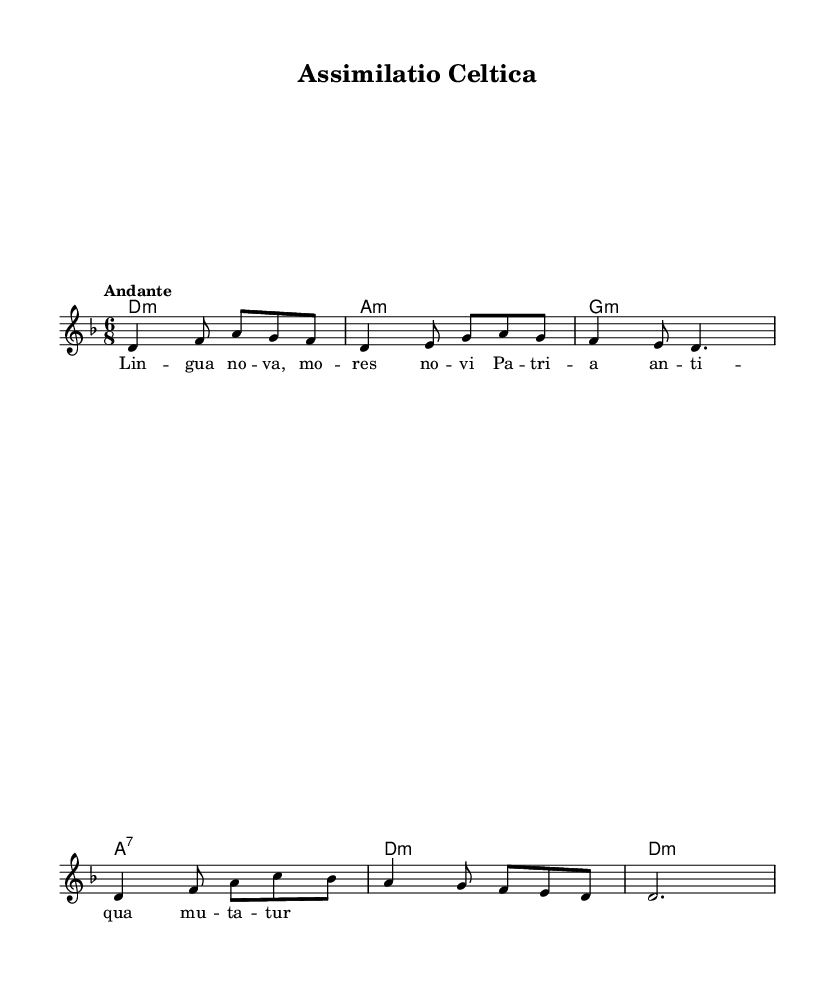What is the key signature of this music? The key signature is indicated at the beginning of the score, which shows one flat, indicating D minor.
Answer: D minor What is the time signature of the piece? The time signature is located next to the key signature at the beginning of the score, showing a 6/8 time signature.
Answer: 6/8 What is the tempo marking given in the score? The tempo marking appears above the staff and states "Andante," which indicates a moderately slow pace.
Answer: Andante How many measures are there in the melody? The melody is divided into measures, and by counting them, we find there are a total of 6 measures presented in the music.
Answer: 6 What chord is played in the first measure? The first measure shows the chord labeled as D minor, indicated in the chord names section.
Answer: D minor Which lyric is sung in the first measure? The lyrics begin with "Lin gua nova," which is aligned with the first measure of music.
Answer: Lin gua nova What is the harmonic structure of the piece? By analyzing the harmonic progression given in the chord section, we see it follows the pattern of D minor, A minor, G minor, and A7 chords in the first part.
Answer: D minor, A minor, G minor, A7 